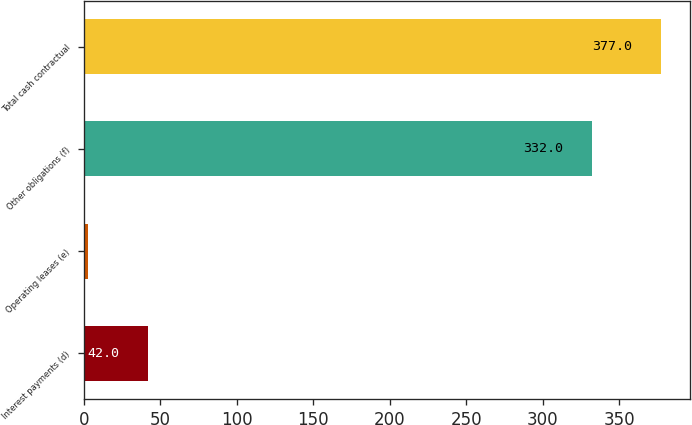Convert chart to OTSL. <chart><loc_0><loc_0><loc_500><loc_500><bar_chart><fcel>Interest payments (d)<fcel>Operating leases (e)<fcel>Other obligations (f)<fcel>Total cash contractual<nl><fcel>42<fcel>3<fcel>332<fcel>377<nl></chart> 